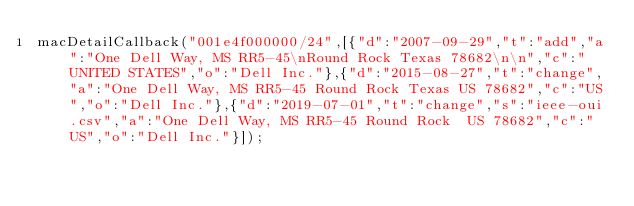<code> <loc_0><loc_0><loc_500><loc_500><_JavaScript_>macDetailCallback("001e4f000000/24",[{"d":"2007-09-29","t":"add","a":"One Dell Way, MS RR5-45\nRound Rock Texas 78682\n\n","c":"UNITED STATES","o":"Dell Inc."},{"d":"2015-08-27","t":"change","a":"One Dell Way, MS RR5-45 Round Rock Texas US 78682","c":"US","o":"Dell Inc."},{"d":"2019-07-01","t":"change","s":"ieee-oui.csv","a":"One Dell Way, MS RR5-45 Round Rock  US 78682","c":"US","o":"Dell Inc."}]);
</code> 